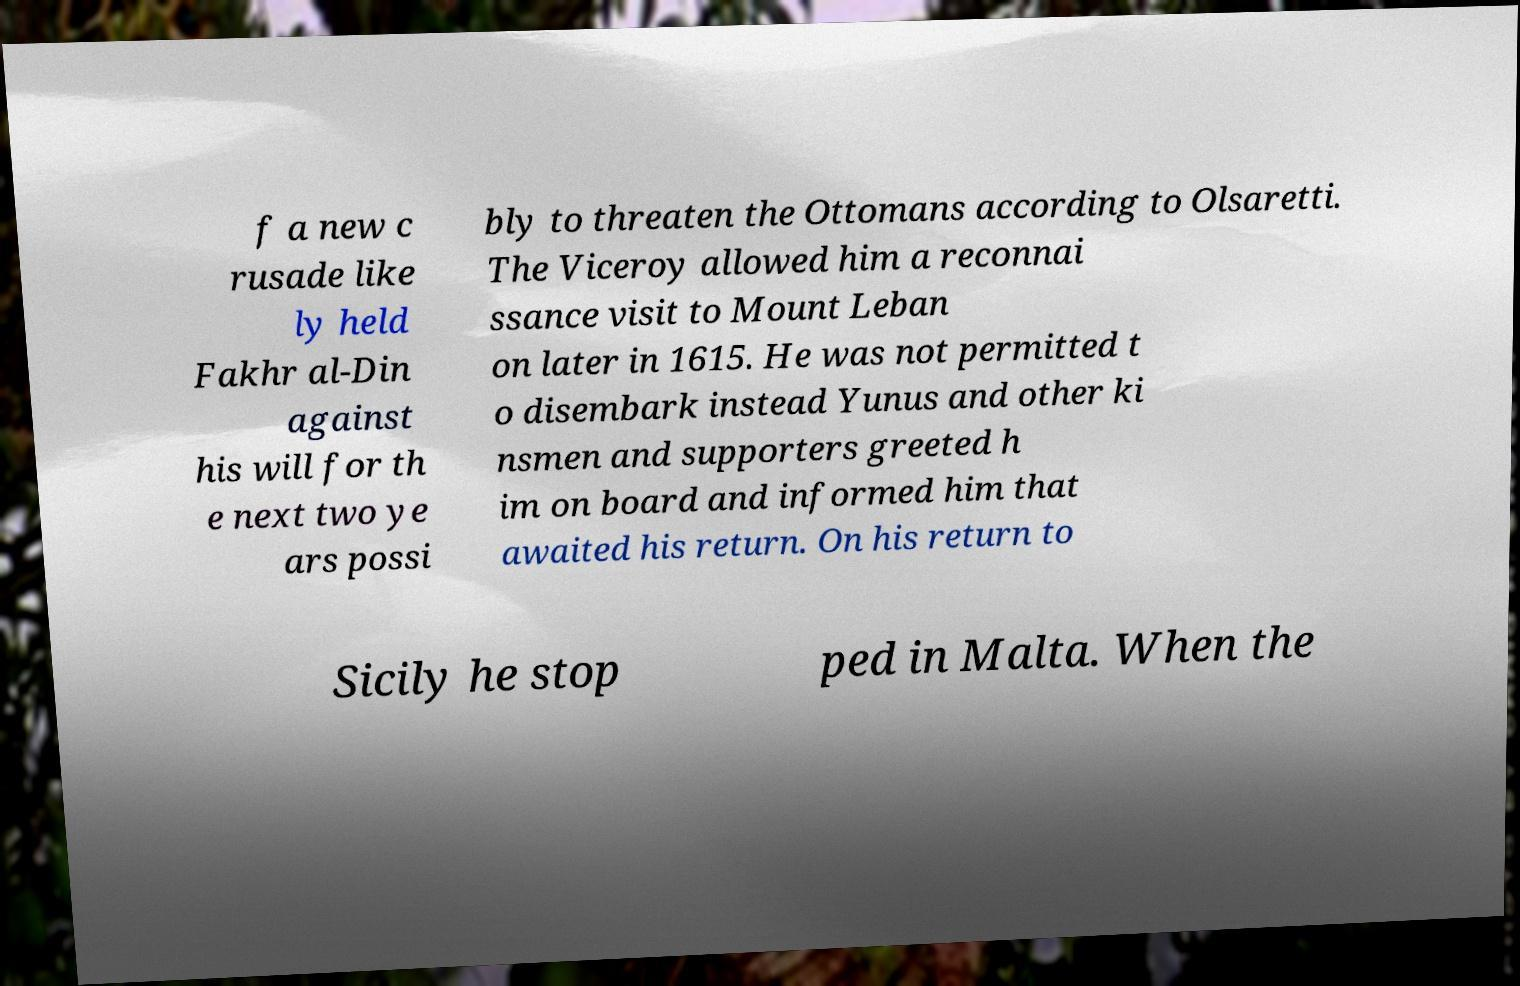What messages or text are displayed in this image? I need them in a readable, typed format. f a new c rusade like ly held Fakhr al-Din against his will for th e next two ye ars possi bly to threaten the Ottomans according to Olsaretti. The Viceroy allowed him a reconnai ssance visit to Mount Leban on later in 1615. He was not permitted t o disembark instead Yunus and other ki nsmen and supporters greeted h im on board and informed him that awaited his return. On his return to Sicily he stop ped in Malta. When the 